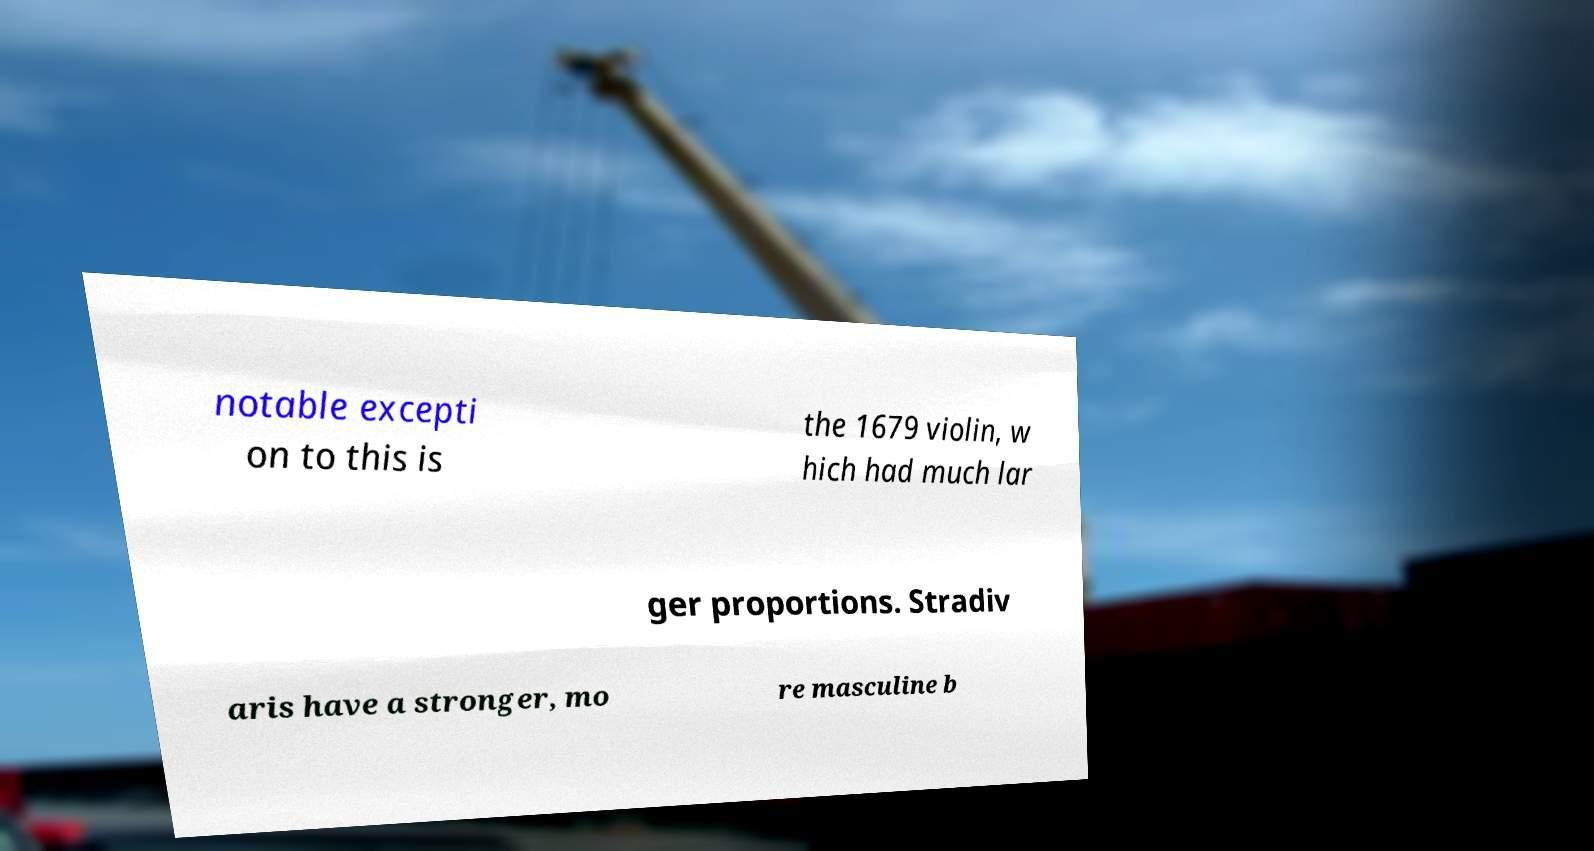Can you read and provide the text displayed in the image?This photo seems to have some interesting text. Can you extract and type it out for me? notable excepti on to this is the 1679 violin, w hich had much lar ger proportions. Stradiv aris have a stronger, mo re masculine b 